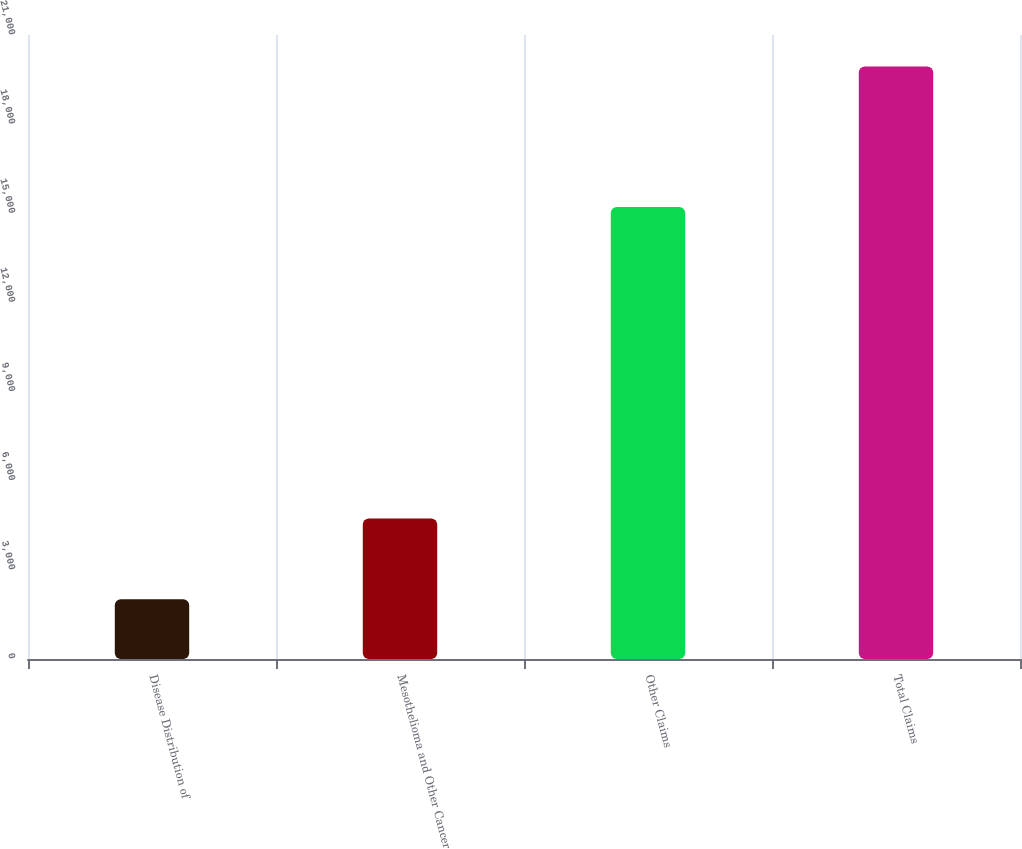Convert chart to OTSL. <chart><loc_0><loc_0><loc_500><loc_500><bar_chart><fcel>Disease Distribution of<fcel>Mesothelioma and Other Cancer<fcel>Other Claims<fcel>Total Claims<nl><fcel>2009<fcel>4727<fcel>15213<fcel>19940<nl></chart> 